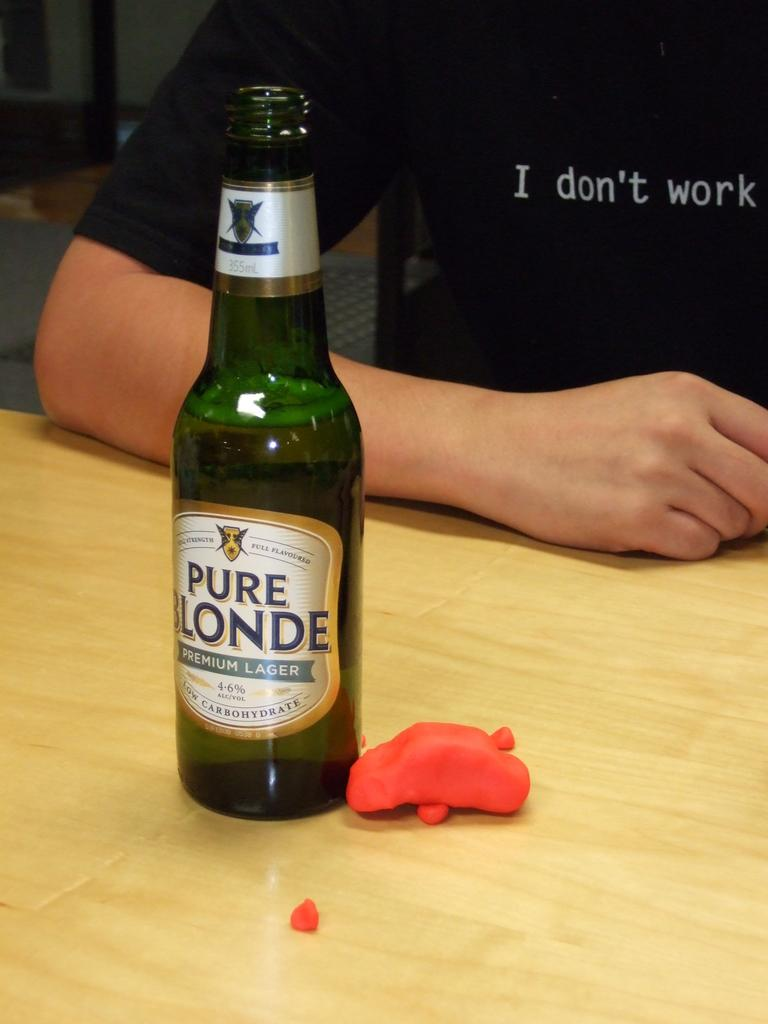<image>
Create a compact narrative representing the image presented. A bottle of Pure Blonde sits on a table in front of a guy wearing a shirt that says I don't work. 